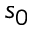<formula> <loc_0><loc_0><loc_500><loc_500>s _ { 0 }</formula> 